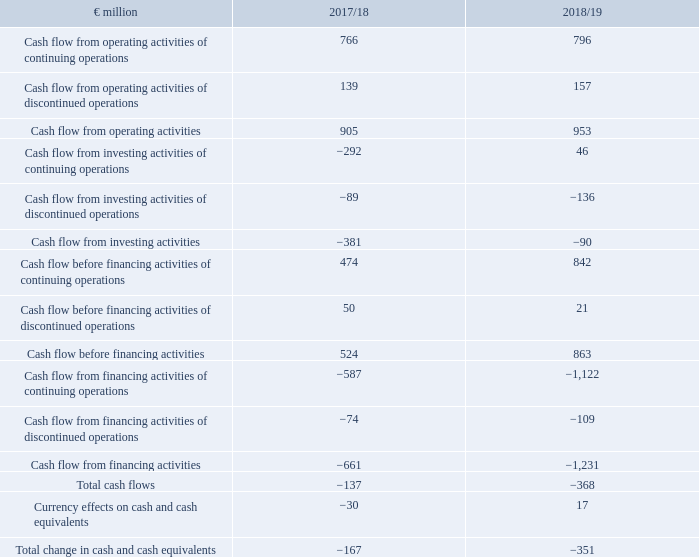CASH FLOW STATEMENT1
1 Abridged version. The complete version is shown in the consolidated financial statements.
What version is the cash flow statement in the table in? Abridged version. Where can the complete version of the cash flow statement be found? The complete version is shown in the consolidated financial statements. What is the Cash flow from operating activities in FY2019?
Answer scale should be: million. 953. In which year was the Cash flow from operating activities larger? 953>905
Answer: 2018/19. What was the change in cash flow from operating activities in FY2019 from FY2018?
Answer scale should be: million. 953-905
Answer: 48. What was the percentage change in cash flow from operating activities in FY2019 from FY2018?
Answer scale should be: percent. (953-905)/905
Answer: 5.3. 